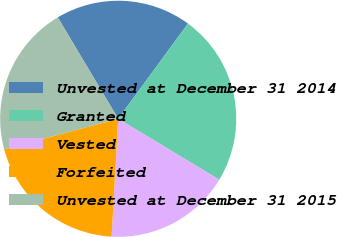Convert chart to OTSL. <chart><loc_0><loc_0><loc_500><loc_500><pie_chart><fcel>Unvested at December 31 2014<fcel>Granted<fcel>Vested<fcel>Forfeited<fcel>Unvested at December 31 2015<nl><fcel>18.62%<fcel>23.57%<fcel>17.25%<fcel>19.96%<fcel>20.59%<nl></chart> 